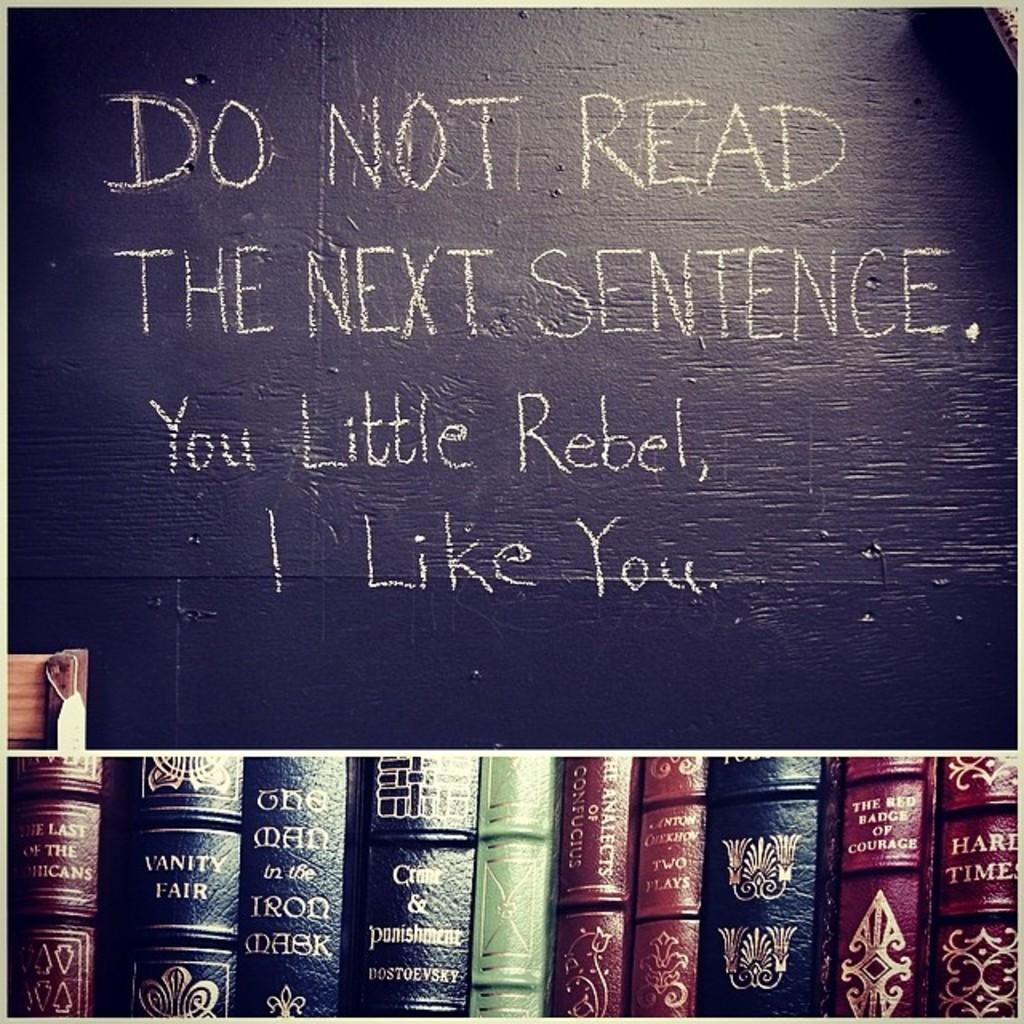<image>
Share a concise interpretation of the image provided. You Little Rebel, I Like you, is written on a blackboard above a row of books 